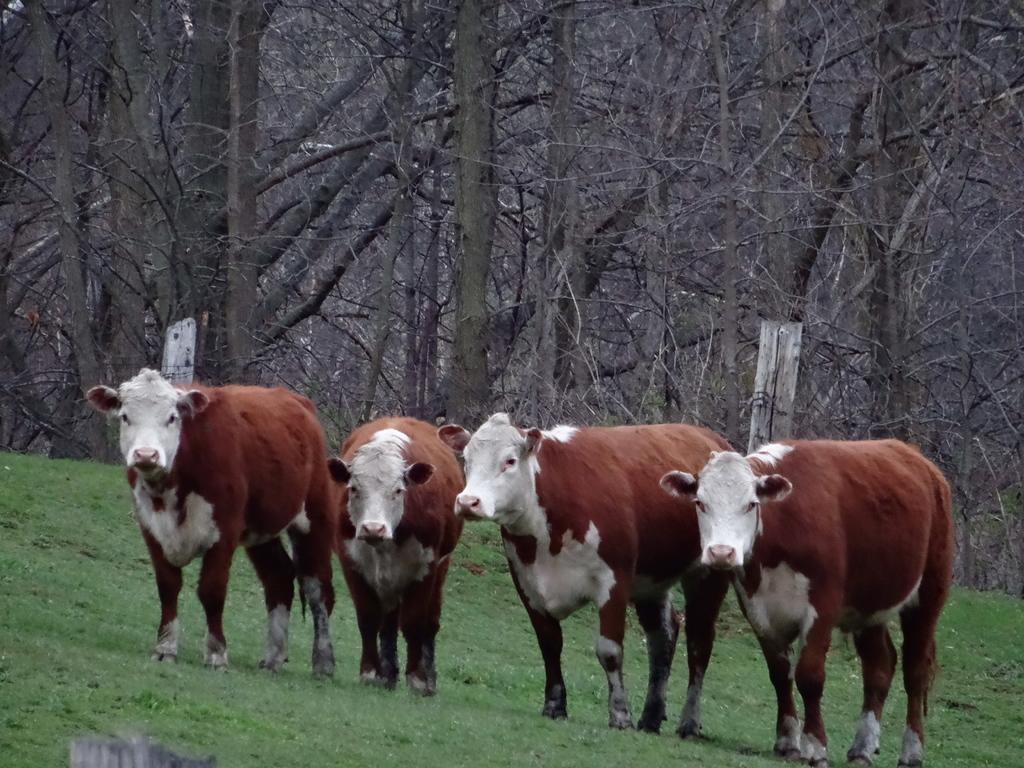How many cows are in the image? There are four cows in the image. What colors are the cows? The cows are brown and white in color. Where are the cows located in the image? The cows are standing on the ground. What can be seen in the background of the image? There are trees in the background of the image. What type of button is the cow wearing in the image? There are no buttons present in the image, as the cows are not wearing any clothing or accessories. 